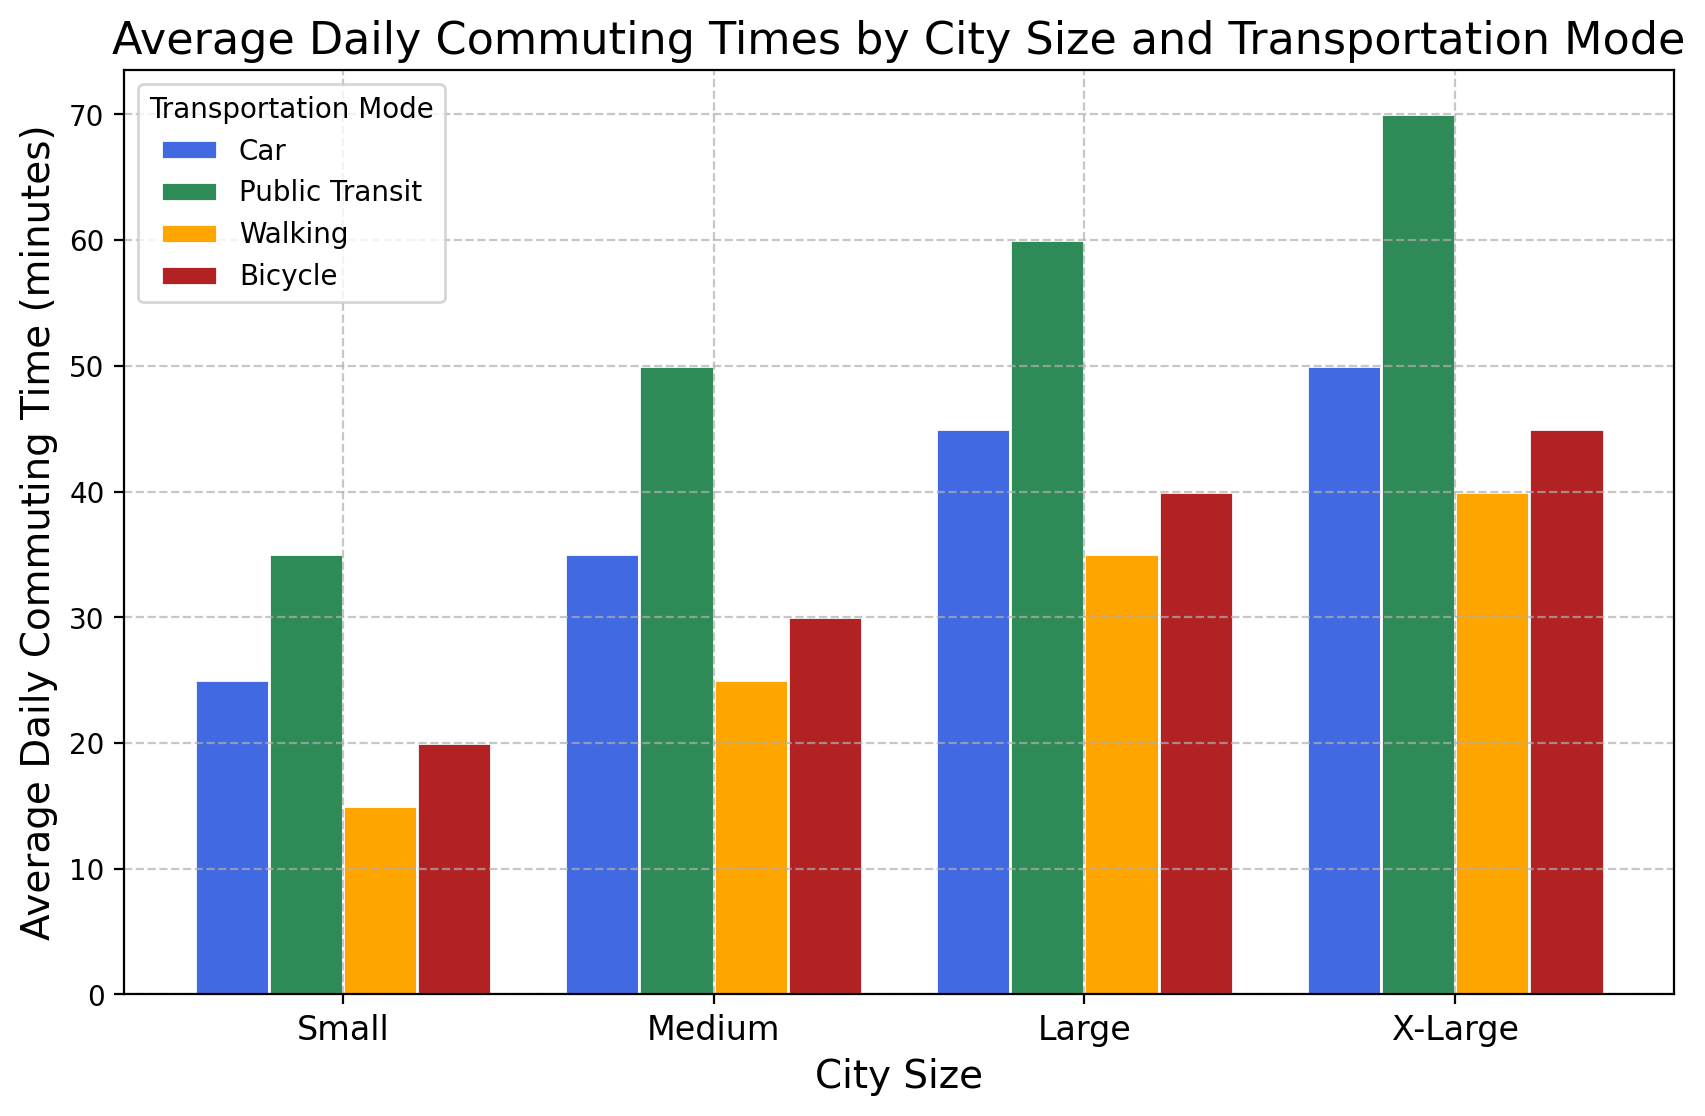What city size has the highest average daily commuting time using public transit? The height of the bars for public transit represents the average daily commuting time. The highest bar in the public transit category corresponds to X-Large city size.
Answer: X-Large Which transportation mode has the lowest average commuting time in small cities? By comparing the heights of the bars in the small city category, the walking bar appears to be the shortest.
Answer: Walking What is the difference in average commuting times by car between small and X-Large cities? The heights of the car bars for small and X-Large cities are 25 and 50 minutes respectively. The difference is 50 - 25.
Answer: 25 minutes How does the average biking time compare between medium-sized and large cities? The heights of the biking bars for medium and large cities are 30 and 40 minutes respectively. Large cities have higher average biking time.
Answer: Larger in large cities What is the total average commuting time for all transportation modes in medium-sized cities? Sum the heights of the bars for medium cities for all transportation modes: Car (35) + Public Transit (50) + Walking (25) + Bicycle (30) = 140 minutes.
Answer: 140 minutes Which transportation mode shows the most significant increase in commuting times from small to large cities? By comparing the differences in heights between small and large cities for each mode: Car (45-25=20), Public Transit (60-35=25), Walking (35-15=20), Bicycle (40-20=20). Public Transit shows the highest increase.
Answer: Public Transit What is the average commuting time across all transportation modes in X-Large cities? Sum the commuting times for all modes in X-Large cities and divide by the number of modes: (Car 50 + Public Transit 70 + Walking 40 + Bicycle 45) / 4 = 205 / 4.
Answer: 51.25 minutes Between public transit and bicycles, which mode has a higher commuting time in large cities? By comparing the heights of bars for public transit and bicycles in large cities, public transit has a higher commuting time.
Answer: Public Transit What is the ratio of average commuting times by car between small and medium-sized cities? Divide the average commuting time by car in small cities by that in medium-sized cities: 25/35 = 0.714
Answer: 0.714 